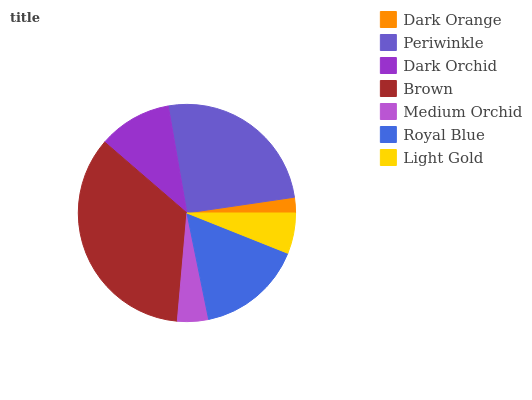Is Dark Orange the minimum?
Answer yes or no. Yes. Is Brown the maximum?
Answer yes or no. Yes. Is Periwinkle the minimum?
Answer yes or no. No. Is Periwinkle the maximum?
Answer yes or no. No. Is Periwinkle greater than Dark Orange?
Answer yes or no. Yes. Is Dark Orange less than Periwinkle?
Answer yes or no. Yes. Is Dark Orange greater than Periwinkle?
Answer yes or no. No. Is Periwinkle less than Dark Orange?
Answer yes or no. No. Is Dark Orchid the high median?
Answer yes or no. Yes. Is Dark Orchid the low median?
Answer yes or no. Yes. Is Periwinkle the high median?
Answer yes or no. No. Is Dark Orange the low median?
Answer yes or no. No. 